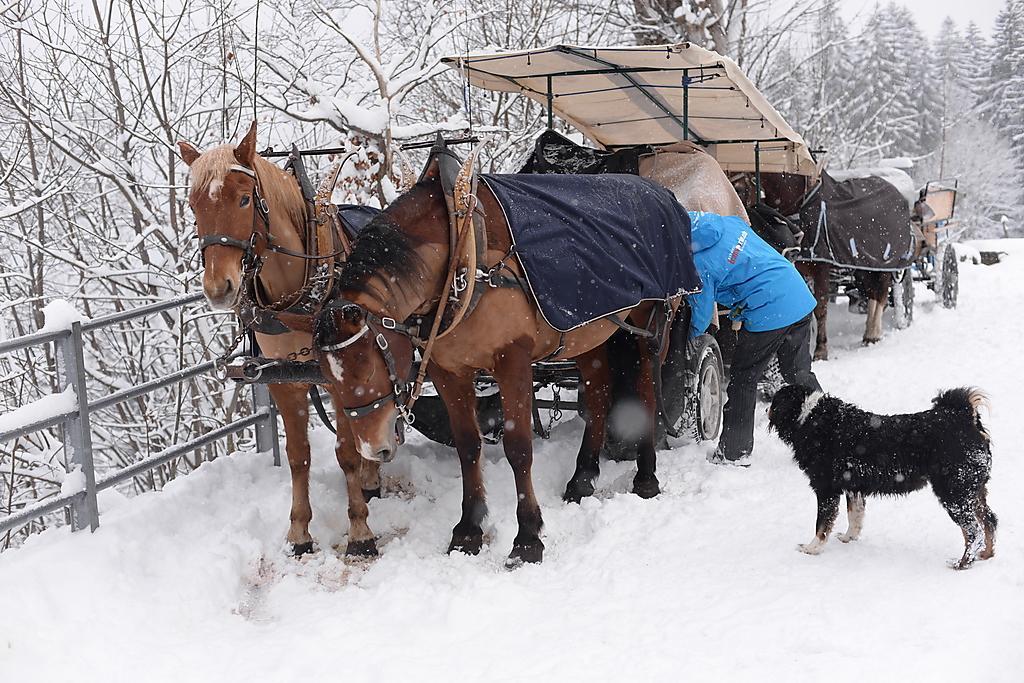Please provide a concise description of this image. In the image in the center, we can see horses and wheel carts, which are attached to the horses. On the horses,we can see some clothes. And we can see one tent, one person standing and one dog, which is in black color. In the background there is a fence, trees and snow. 